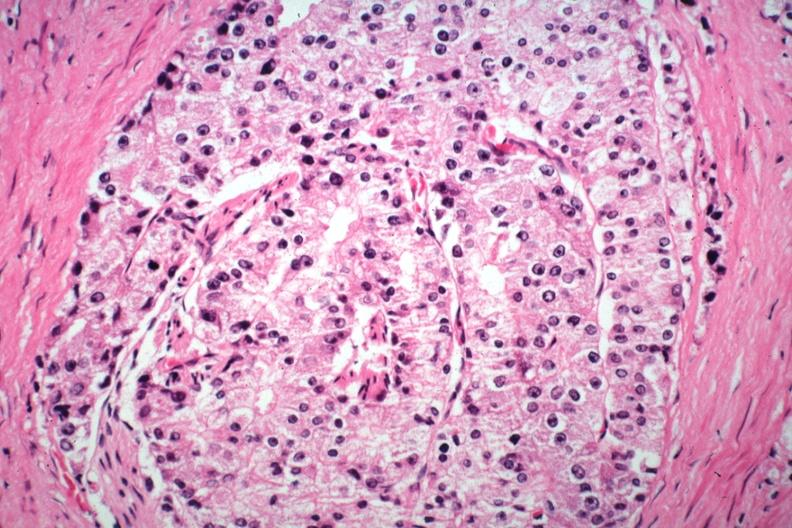what does this image show?
Answer the question using a single word or phrase. Typical histology and cytology of lesion 